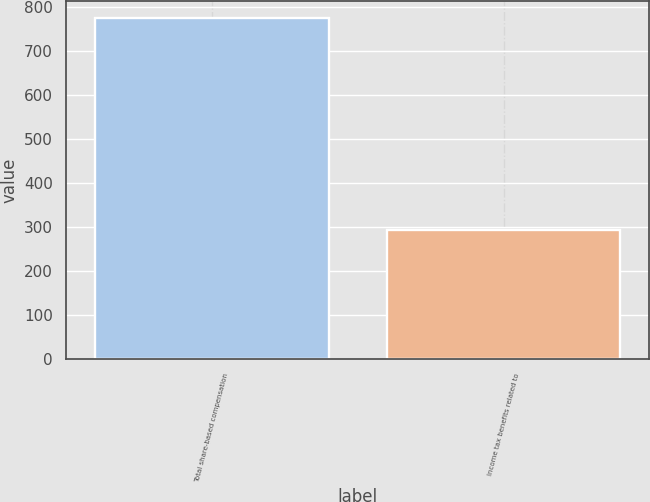Convert chart to OTSL. <chart><loc_0><loc_0><loc_500><loc_500><bar_chart><fcel>Total share-based compensation<fcel>Income tax benefits related to<nl><fcel>774<fcel>294<nl></chart> 